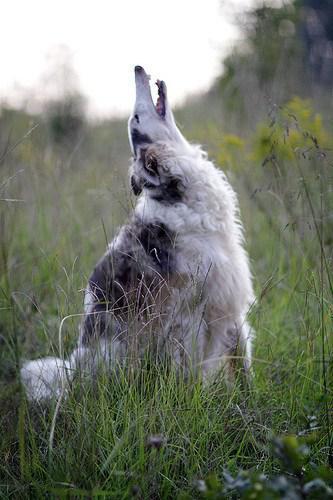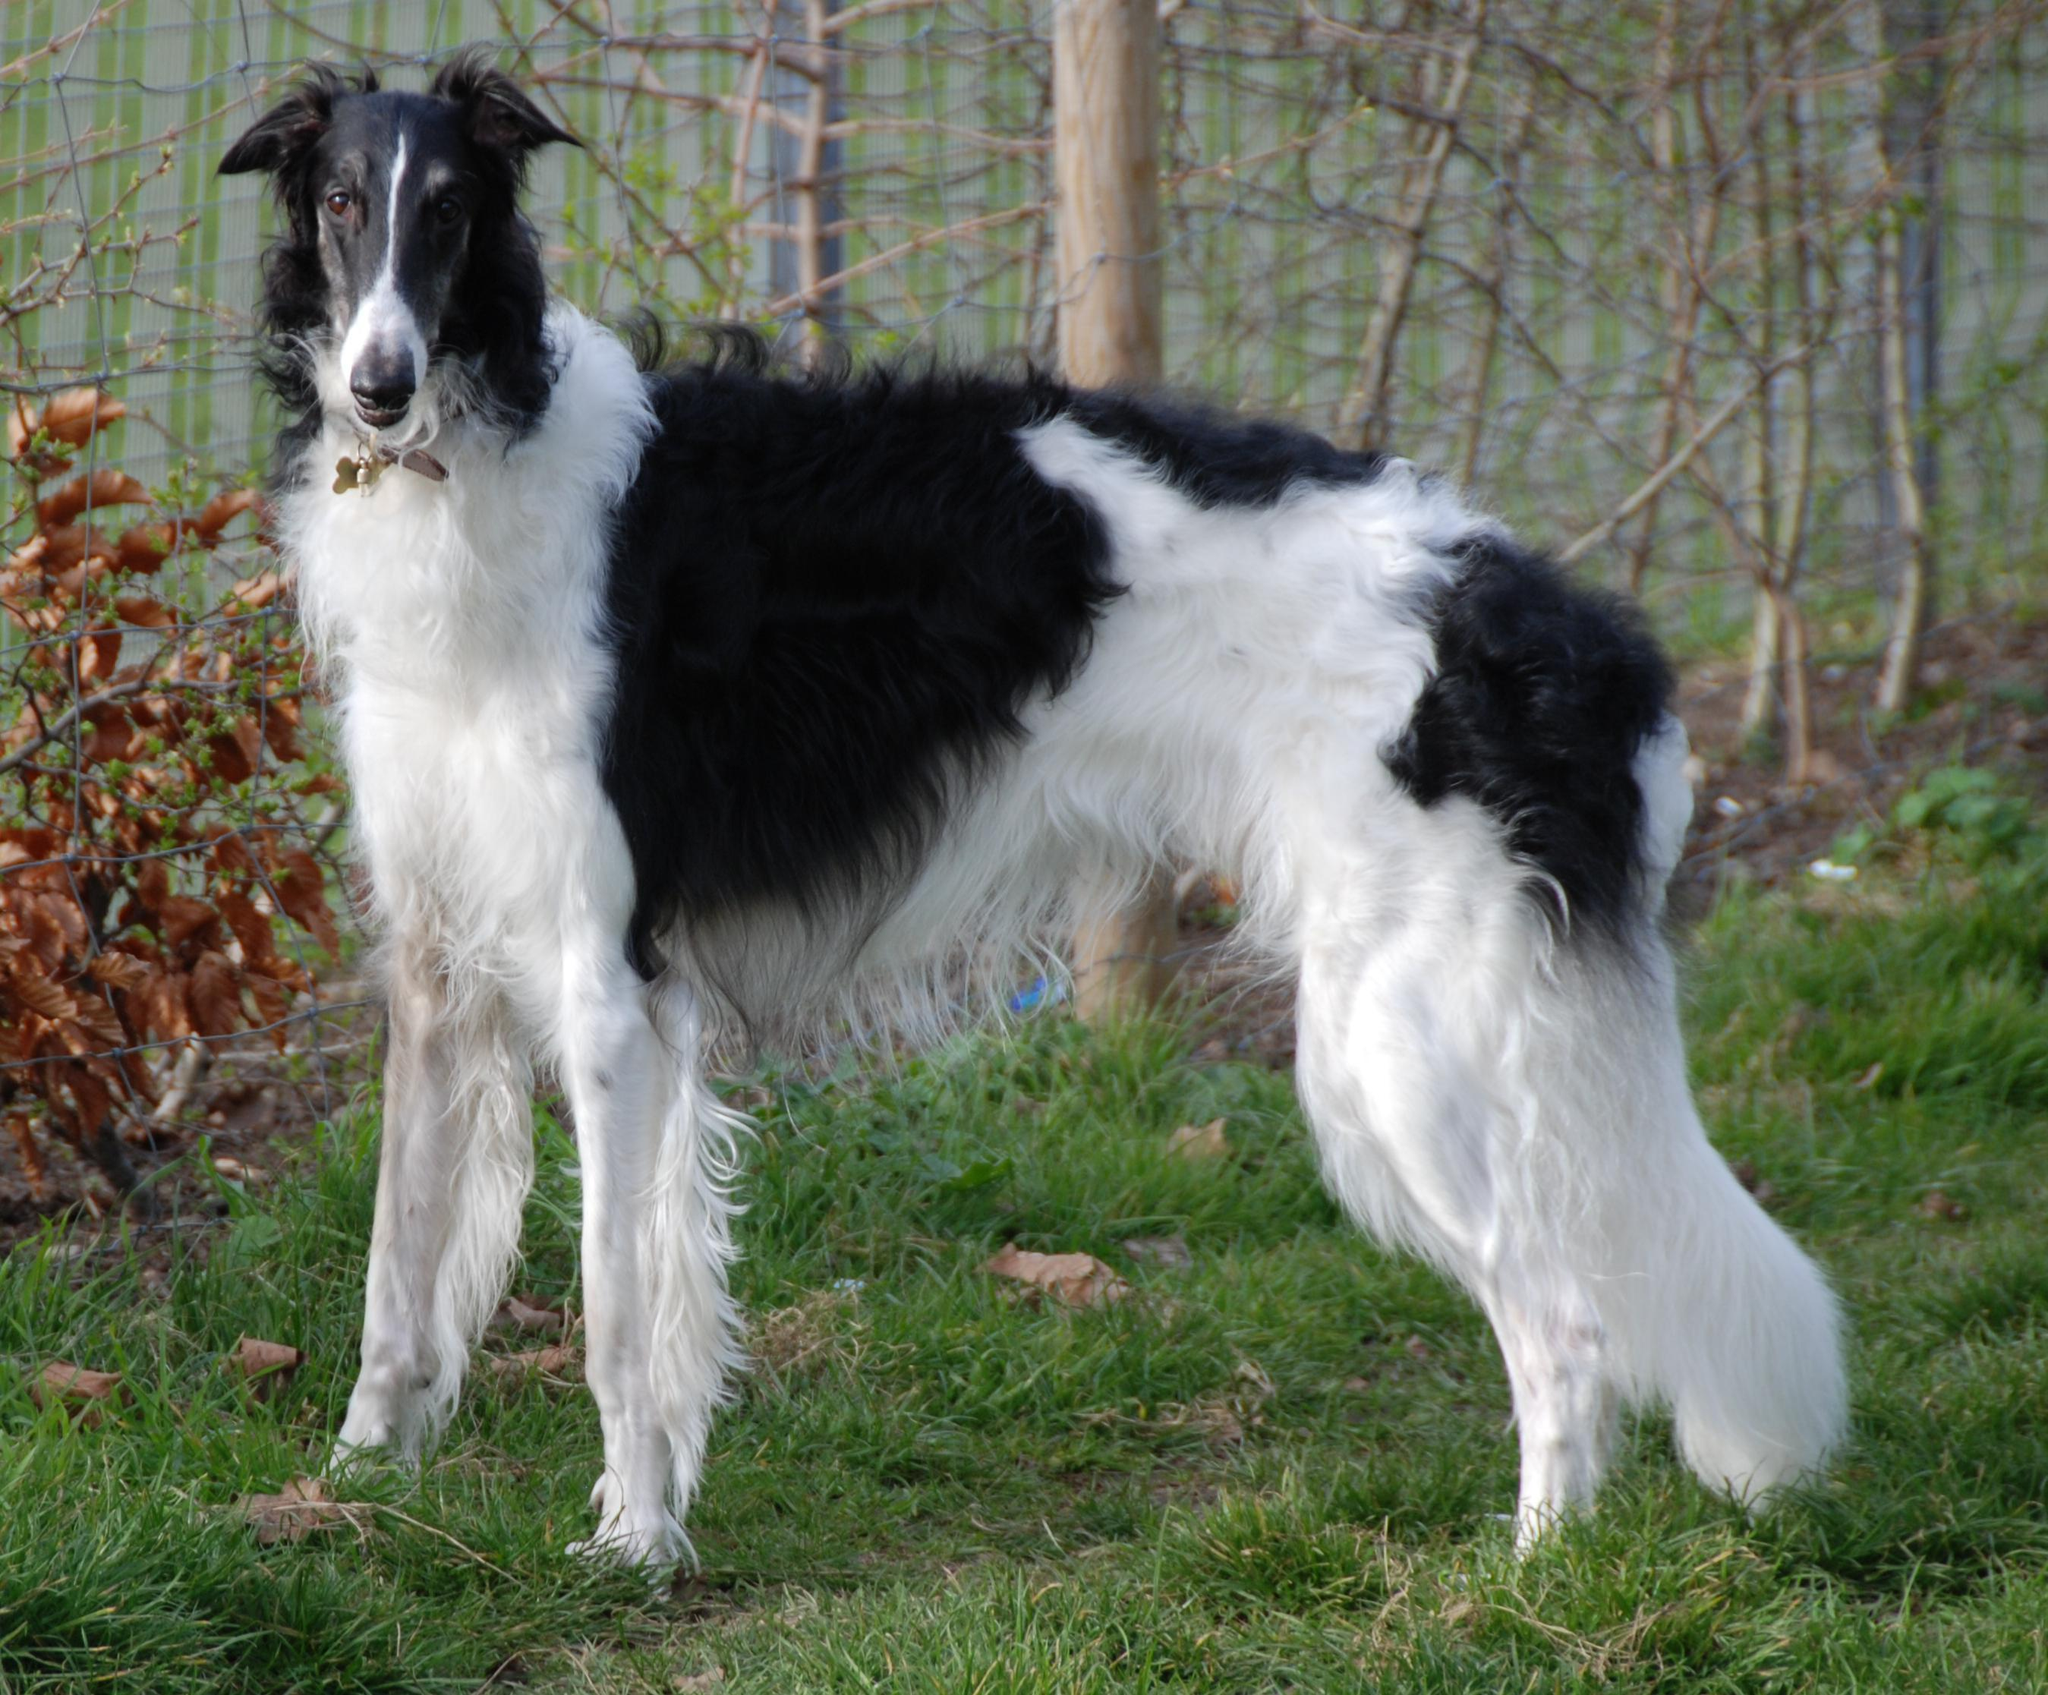The first image is the image on the left, the second image is the image on the right. Assess this claim about the two images: "An image shows a young animal of some type close to an adult hound with its body turned rightward.". Correct or not? Answer yes or no. No. The first image is the image on the left, the second image is the image on the right. For the images displayed, is the sentence "There is one dog in a grassy area in the image on the left." factually correct? Answer yes or no. Yes. 